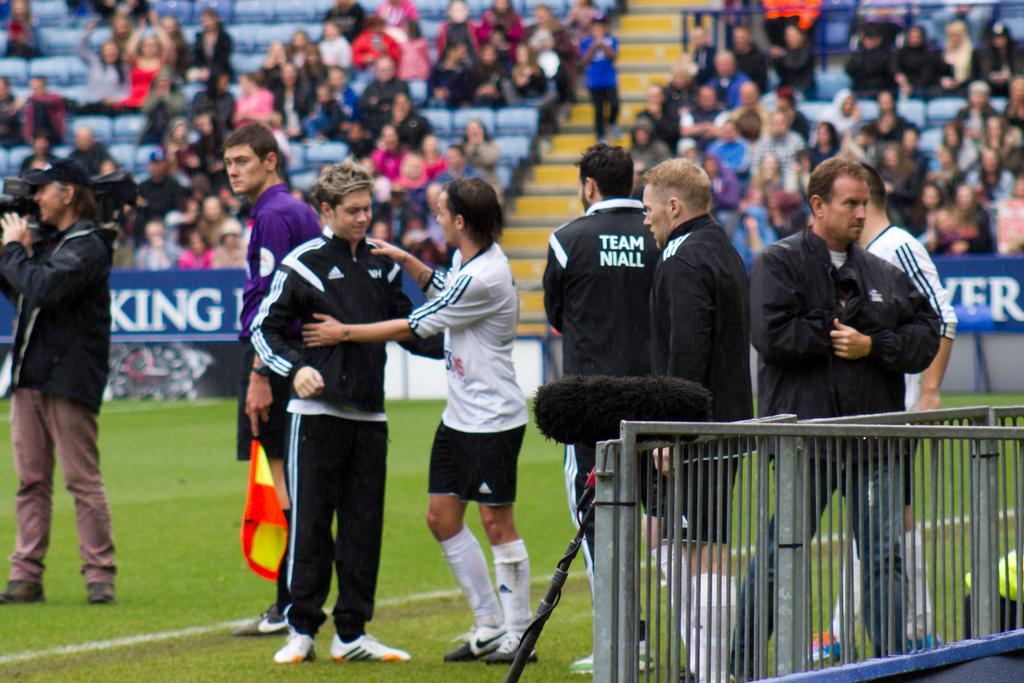How would you summarize this image in a sentence or two? In the center of the image we can see people standing. The man standing on the left is holding a camera. In the background there is crowd. On the right there is a fence. 